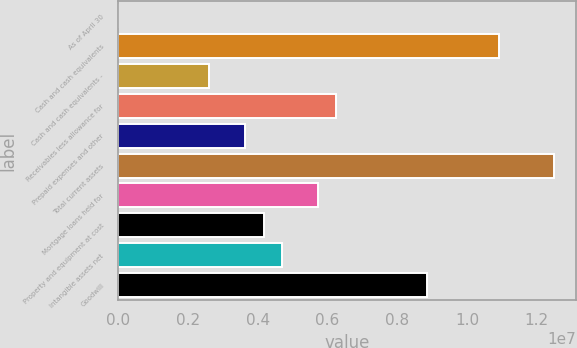Convert chart to OTSL. <chart><loc_0><loc_0><loc_500><loc_500><bar_chart><fcel>As of April 30<fcel>Cash and cash equivalents<fcel>Cash and cash equivalents -<fcel>Receivables less allowance for<fcel>Prepaid expenses and other<fcel>Total current assets<fcel>Mortgage loans held for<fcel>Property and equipment at cost<fcel>Intangible assets net<fcel>Goodwill<nl><fcel>2011<fcel>1.09345e+07<fcel>2.60499e+06<fcel>6.24915e+06<fcel>3.64618e+06<fcel>1.24963e+07<fcel>5.72856e+06<fcel>4.16677e+06<fcel>4.68737e+06<fcel>8.85213e+06<nl></chart> 